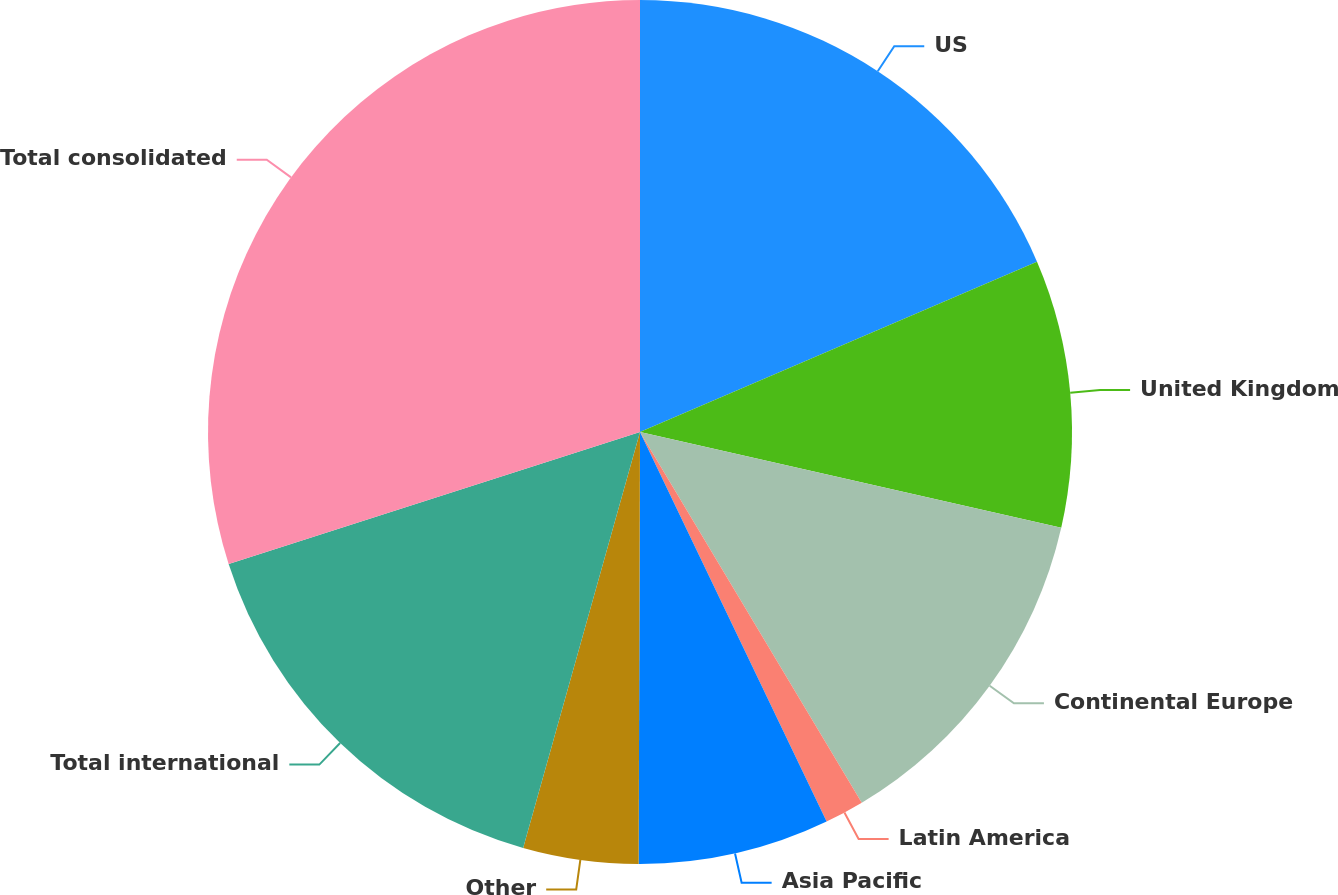<chart> <loc_0><loc_0><loc_500><loc_500><pie_chart><fcel>US<fcel>United Kingdom<fcel>Continental Europe<fcel>Latin America<fcel>Asia Pacific<fcel>Other<fcel>Total international<fcel>Total consolidated<nl><fcel>18.55%<fcel>10.01%<fcel>12.86%<fcel>1.47%<fcel>7.16%<fcel>4.31%<fcel>15.7%<fcel>29.94%<nl></chart> 